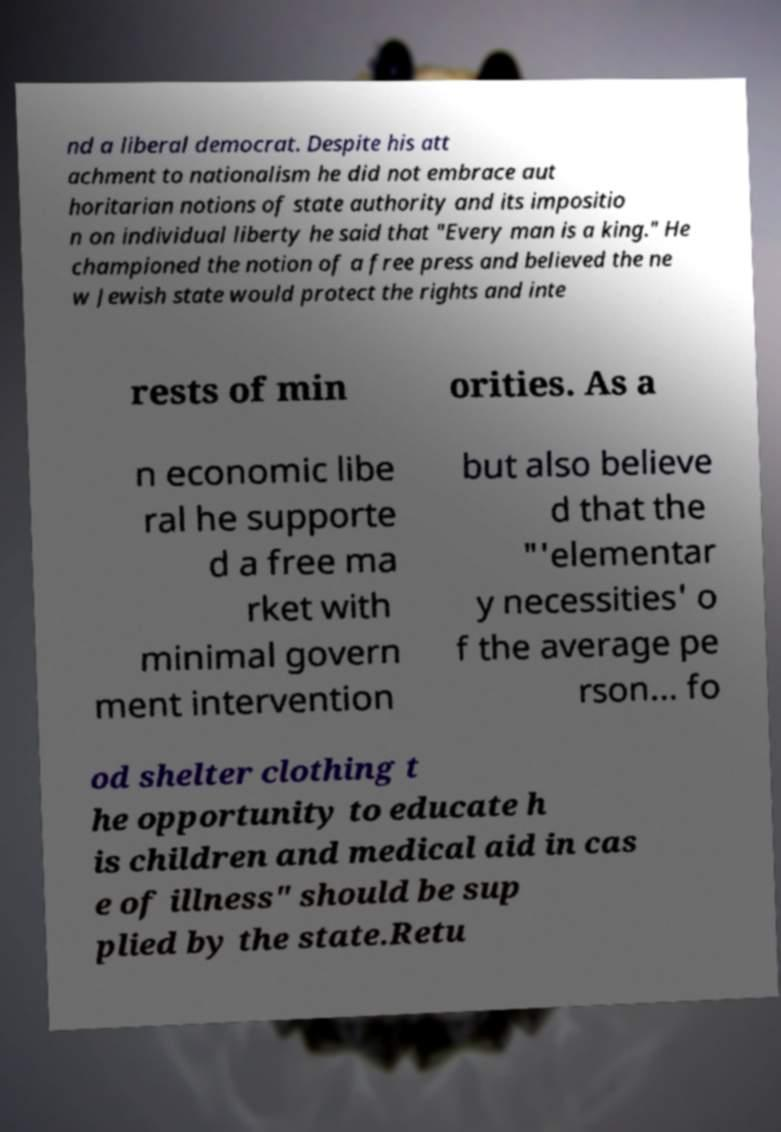Please identify and transcribe the text found in this image. nd a liberal democrat. Despite his att achment to nationalism he did not embrace aut horitarian notions of state authority and its impositio n on individual liberty he said that "Every man is a king." He championed the notion of a free press and believed the ne w Jewish state would protect the rights and inte rests of min orities. As a n economic libe ral he supporte d a free ma rket with minimal govern ment intervention but also believe d that the "'elementar y necessities' o f the average pe rson... fo od shelter clothing t he opportunity to educate h is children and medical aid in cas e of illness" should be sup plied by the state.Retu 